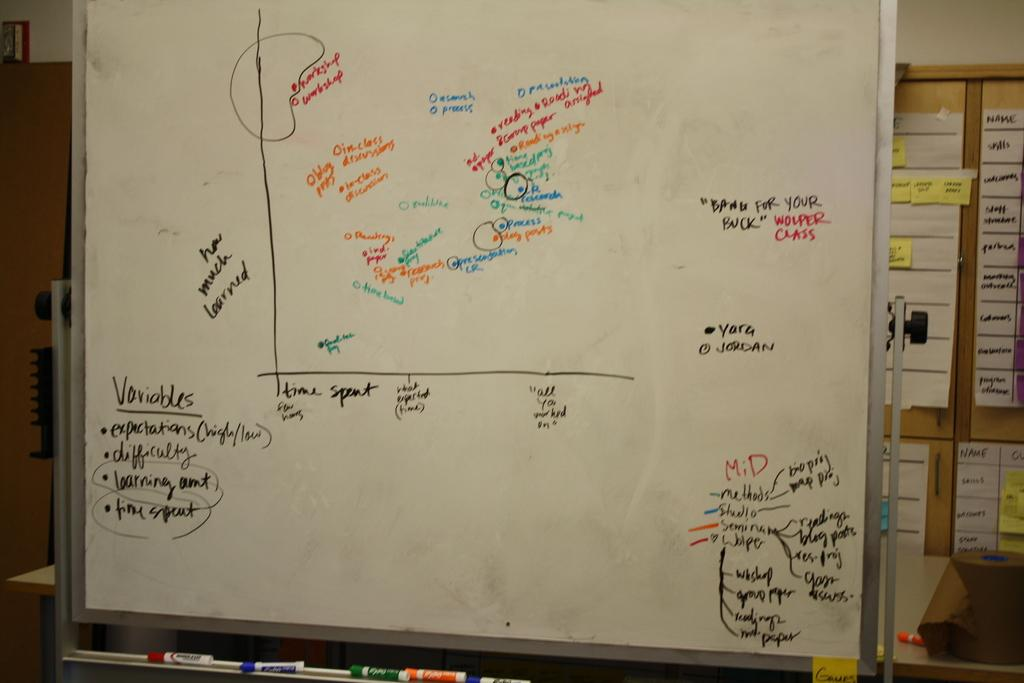Provide a one-sentence caption for the provided image. A white board with an bar graph and variables wrote on it. 